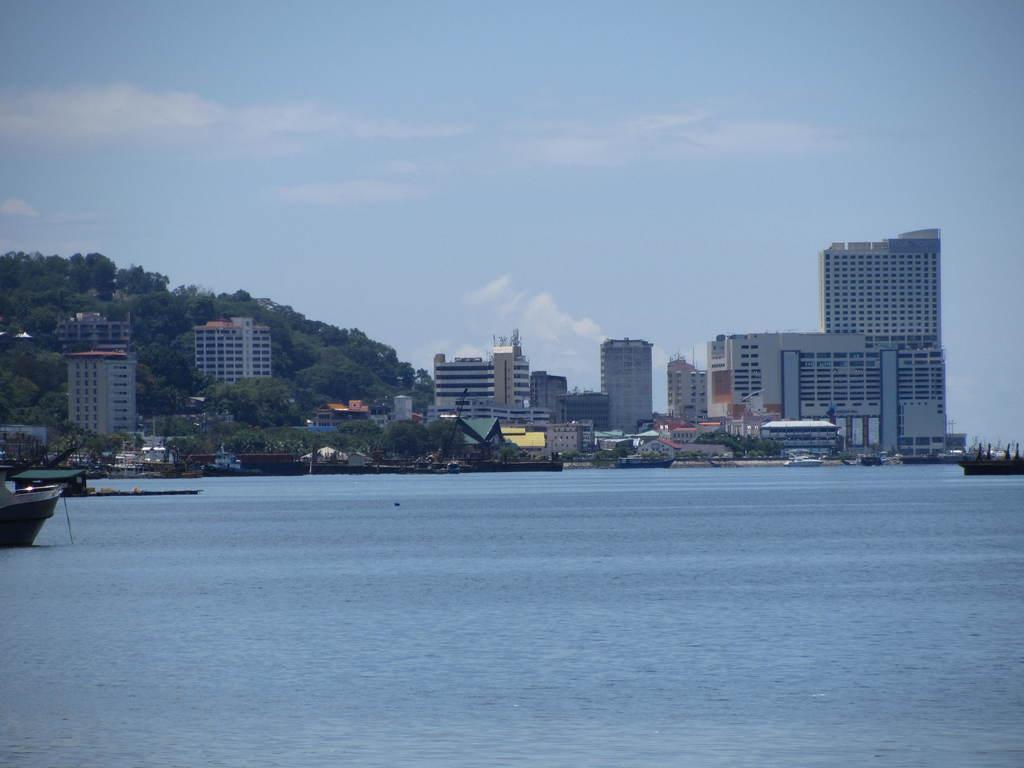Describe this image in one or two sentences. In this picture we can see there are boats on the water. Behind the boats there are trees, buildings and a sky. 